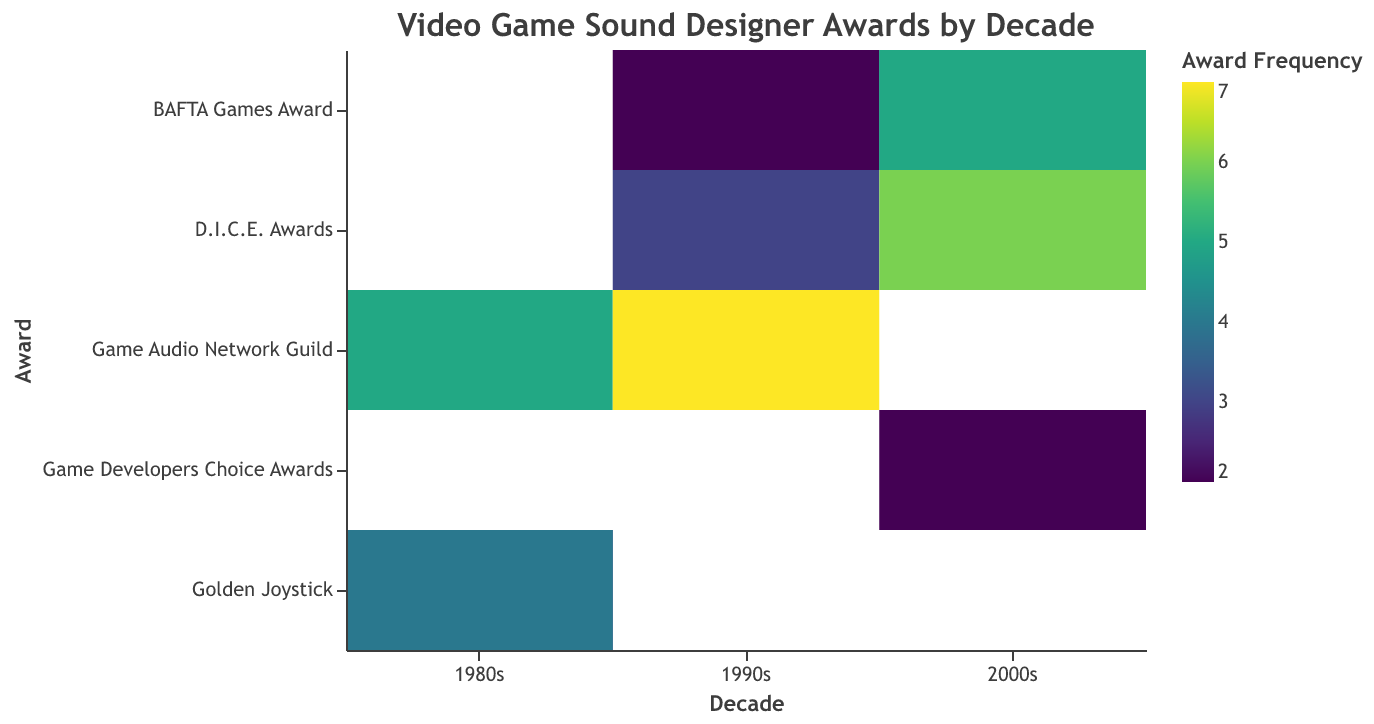What is the title of the heatmap? The title of the heatmap is positioned at the top center of the figure and usually written in a larger or bolder font. It provides a brief description of what the heatmap represents. In this case, the title is "Video Game Sound Designer Awards by Decade."
Answer: Video Game Sound Designer Awards by Decade Which sound designer has the most frequent award in the 1990s? To find this, we need to look at the decade "1990s" on the x-axis and identify which sound designer has the highest frequency among the listed awards. Nobuo Uematsu with 7 awards for "Game Audio Network Guild" is the highest.
Answer: Nobuo Uematsu How many total awards did sound designers win in the 2000s? Add up the frequencies of all awards in the column for the decade "2000s." The frequencies are 4 (BAFTA Games Award), 6 (D.I.C.E. Awards), 2 (Game Developers Choice Awards), and 5 (BAFTA Games Award). Sum: 4 + 6 + 2 + 5 = 17.
Answer: 17 Which award has the highest frequency in the 1980s? To determine this, examine the frequencies in the 1980s column. Compare the frequencies for each award: 3 (Golden Joystick, Rob Hubbard), 5 (Game Audio Network Guild, Koji Kondo), and 4 (Golden Joystick, Martin Galway). The highest is 5 for "Game Audio Network Guild."
Answer: Game Audio Network Guild Compare the frequency of "Golden Joystick" awards between the 1980s and 2000s. In the 1980s, the "Golden Joystick" awards have frequencies of 3 (Rob Hubbard) and 4 (Martin Galway). Add these together: 3 + 4 = 7. In the 2000s, there are no "Golden Joystick" awards listed. So, 7 in the 1980s vs. 0 in the 2000s.
Answer: 1980s: 7, 2000s: 0 Which sound designer won the Game Audio Network Guild award in the 1980s and what game was it for? Look at the 1980s row and find the cell under the Game Audio Network Guild column. The tooltip for this cell shows that Koji Kondo won the award for "Super Mario Bros."
Answer: Koji Kondo, Super Mario Bros List all the sound designers who won the BAFTA Games Award in the 2000s along with the games they worked on. In the 2000s column, find the cells under the BAFTA Games Award row. The tooltip information shows: Marty O'Donnell (Halo: Combat Evolved) and Koji Kondo (The Legend of Zelda: The Wind Waker).
Answer: Marty O'Donnell (Halo: Combat Evolved), Koji Kondo (The Legend of Zelda: The Wind Waker) 